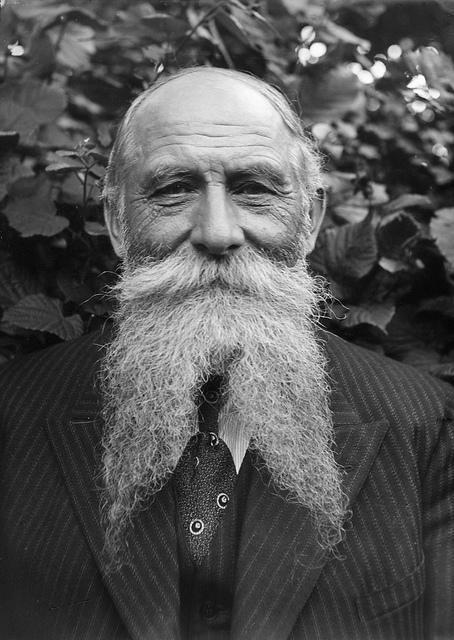How many zebras are eating off the ground?
Give a very brief answer. 0. 